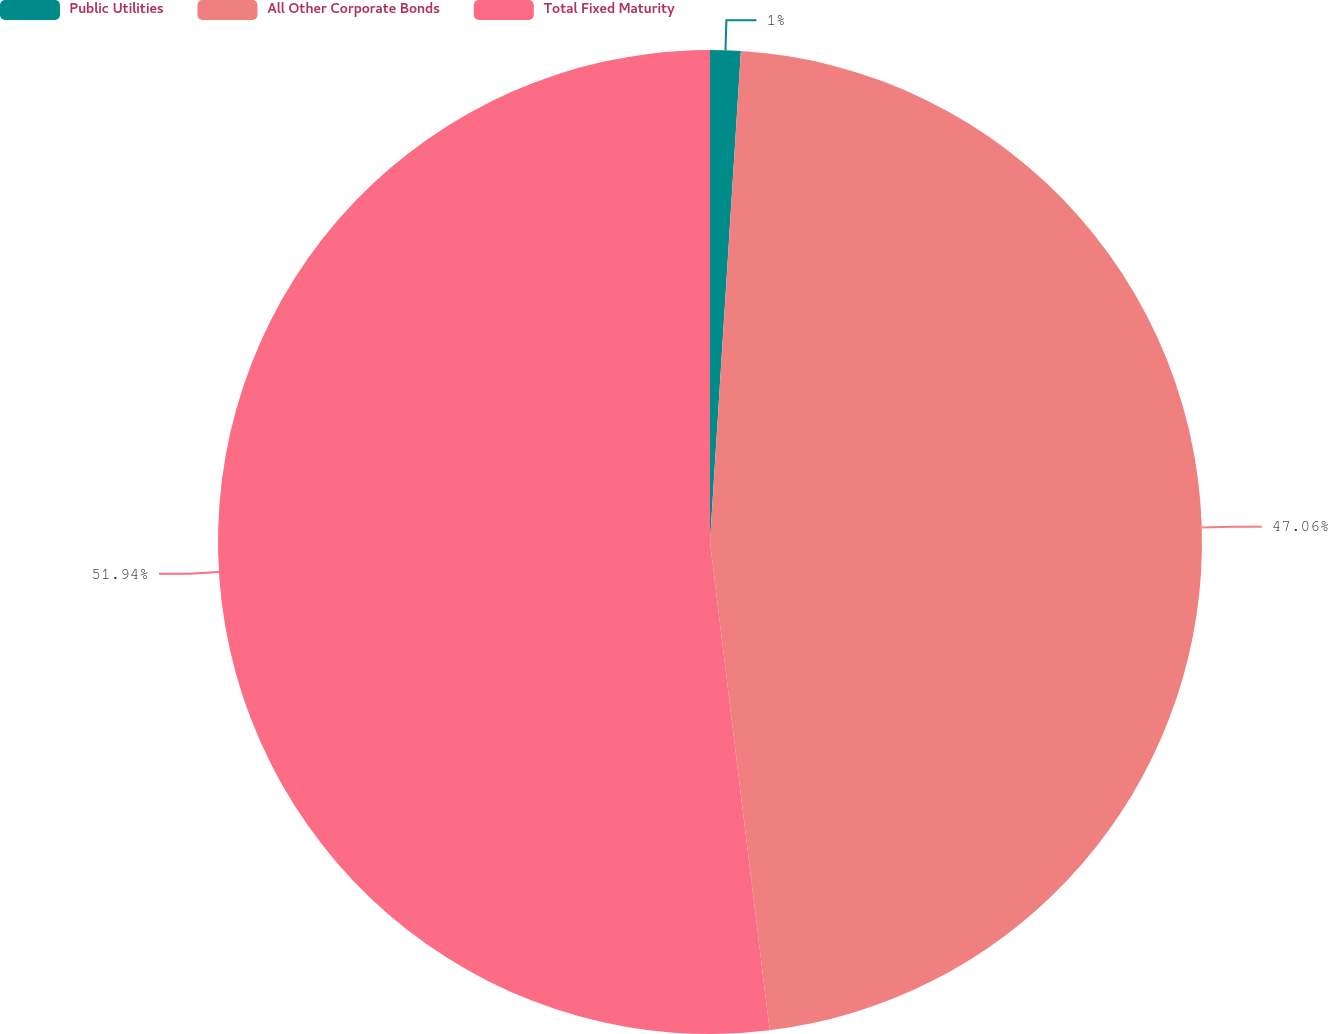Convert chart to OTSL. <chart><loc_0><loc_0><loc_500><loc_500><pie_chart><fcel>Public Utilities<fcel>All Other Corporate Bonds<fcel>Total Fixed Maturity<nl><fcel>1.0%<fcel>47.06%<fcel>51.93%<nl></chart> 